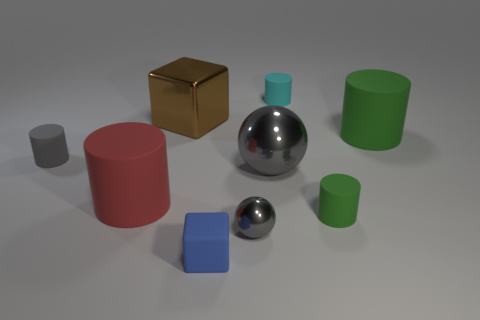Subtract all green cylinders. How many cylinders are left? 3 Subtract all cyan cylinders. How many cylinders are left? 4 Subtract 1 cylinders. How many cylinders are left? 4 Subtract all green cylinders. How many cyan balls are left? 0 Subtract all balls. How many objects are left? 7 Subtract all green cylinders. Subtract all cyan cubes. How many cylinders are left? 3 Subtract all red matte cylinders. Subtract all green objects. How many objects are left? 6 Add 1 cyan rubber things. How many cyan rubber things are left? 2 Add 6 small cyan things. How many small cyan things exist? 7 Subtract 0 yellow cylinders. How many objects are left? 9 